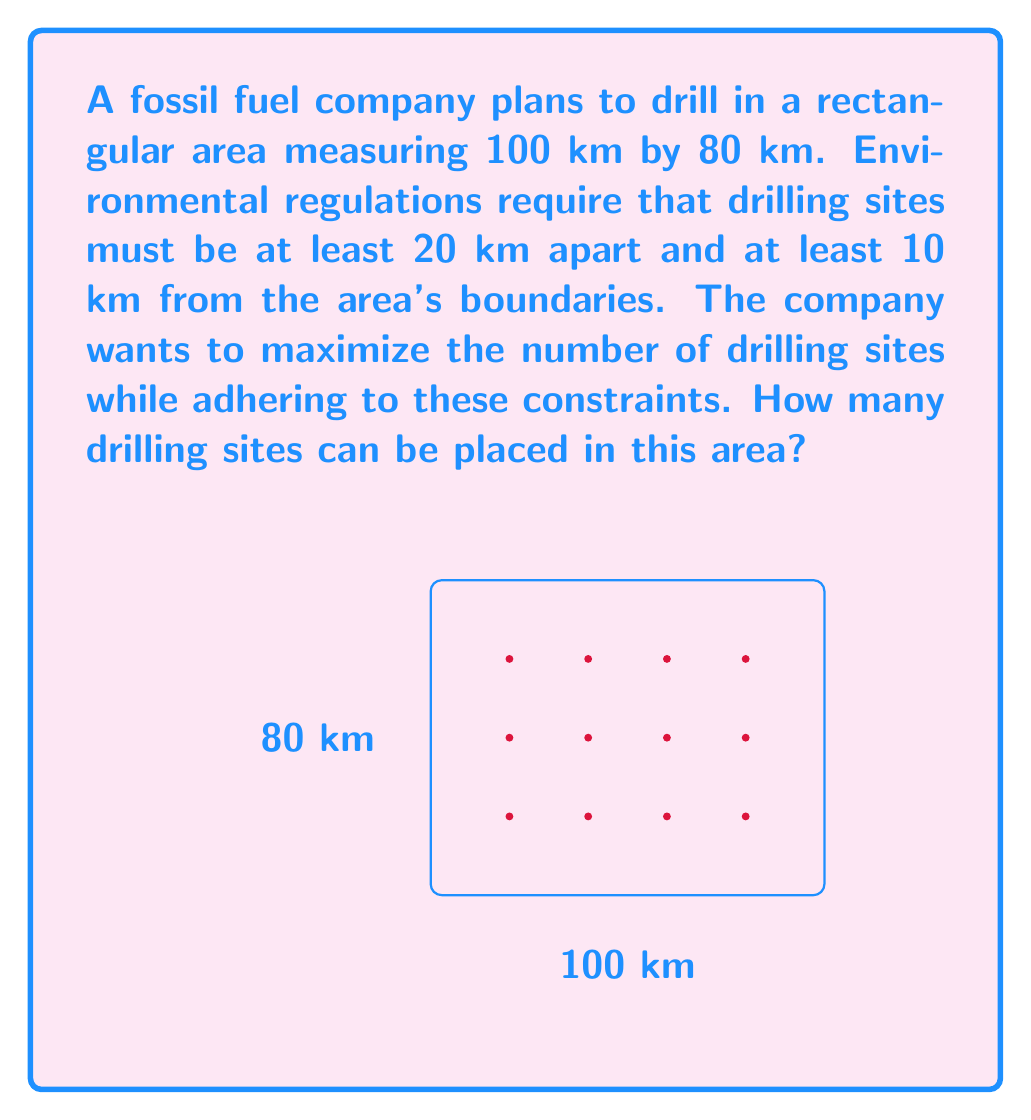Provide a solution to this math problem. To solve this problem, we'll follow these steps:

1) First, we need to determine the effective area where drilling sites can be placed, considering the 10 km buffer from boundaries:
   Effective length = 100 km - (2 * 10 km) = 80 km
   Effective width = 80 km - (2 * 10 km) = 60 km

2) Now, we need to determine how many drilling sites can fit along the length and width, given that they must be at least 20 km apart:
   Sites along length = $\lfloor \frac{80 \text{ km}}{20 \text{ km}} \rfloor = 4$
   Sites along width = $\lfloor \frac{60 \text{ km}}{20 \text{ km}} \rfloor = 3$

   Where $\lfloor \cdot \rfloor$ denotes the floor function (rounding down to the nearest integer).

3) The total number of drilling sites is the product of the number of sites along the length and width:
   Total sites = 4 * 3 = 12

Therefore, the company can place 12 drilling sites in the given area while adhering to the environmental regulations.
Answer: 12 drilling sites 